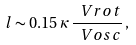Convert formula to latex. <formula><loc_0><loc_0><loc_500><loc_500>l \sim 0 . 1 5 \, \kappa \, \frac { \ V r o t } { \ V o s c } \, ,</formula> 